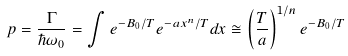<formula> <loc_0><loc_0><loc_500><loc_500>p = \frac { \Gamma } { \hbar { \omega } _ { 0 } } = \int { e ^ { - B _ { 0 } / T } e ^ { - a x ^ { n } / T } d x } \cong \left ( \frac { T } { a } \right ) ^ { 1 / n } e ^ { - B _ { 0 } / T }</formula> 